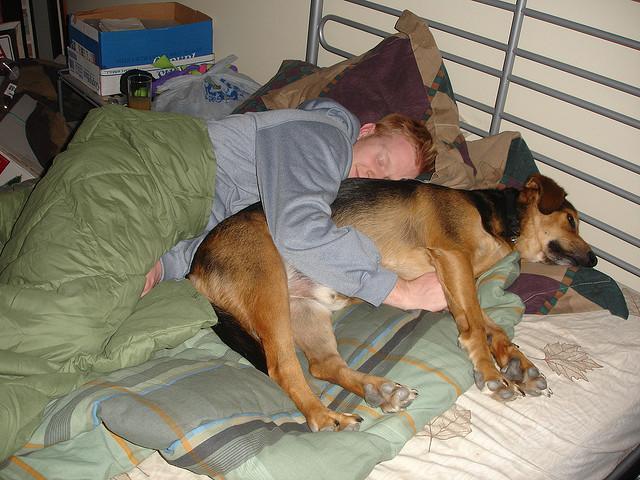How many beds are visible?
Give a very brief answer. 1. How many giraffes are standing up straight?
Give a very brief answer. 0. 